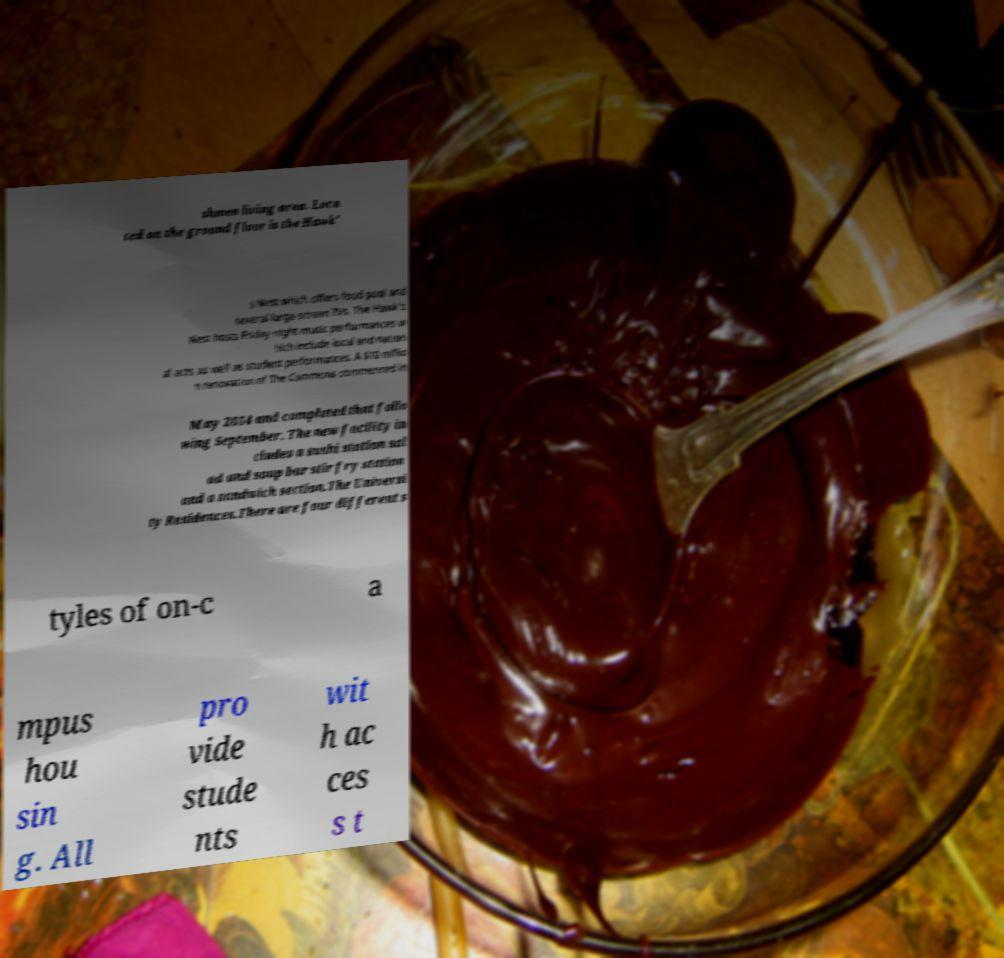What messages or text are displayed in this image? I need them in a readable, typed format. shmen living area. Loca ted on the ground floor is the Hawk' s Nest which offers food pool and several large-screen TVs. The Hawk's Nest hosts Friday-night music performances w hich include local and nation al acts as well as student performances. A $10 millio n renovation of The Commons commenced in May 2014 and completed that follo wing September. The new facility in cludes a sushi station sal ad and soup bar stir fry station and a sandwich section.The Universi ty Residences.There are four different s tyles of on-c a mpus hou sin g. All pro vide stude nts wit h ac ces s t 